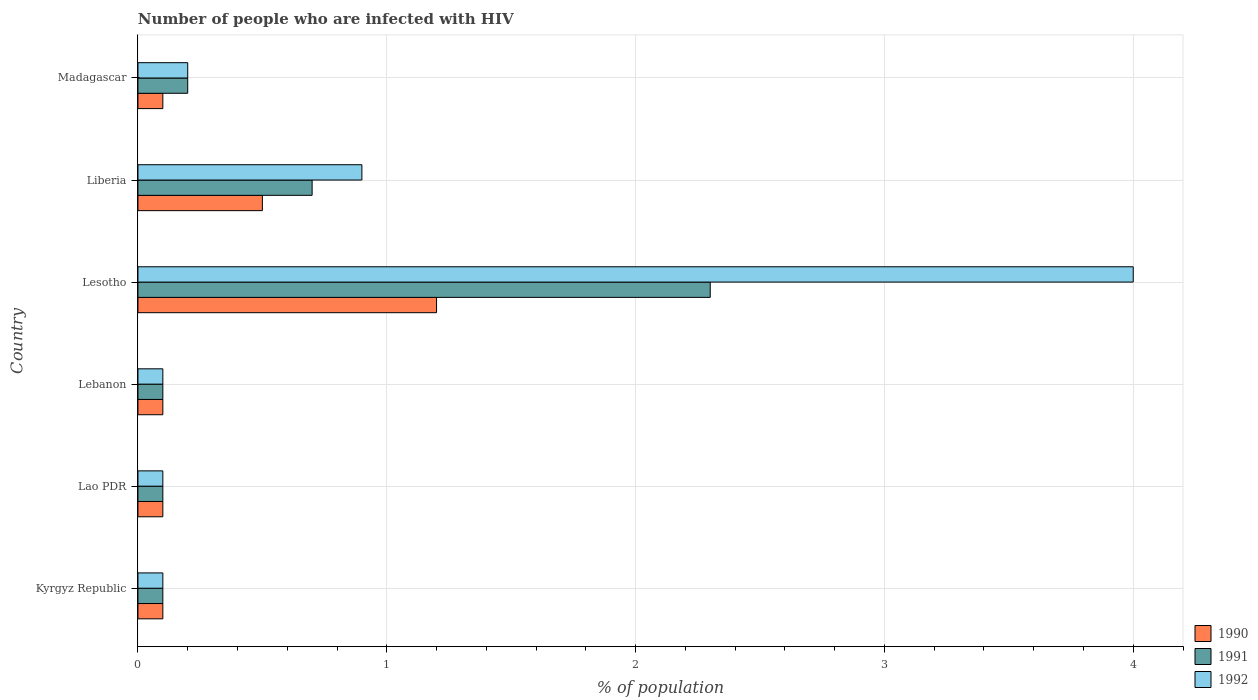How many bars are there on the 2nd tick from the top?
Make the answer very short. 3. How many bars are there on the 3rd tick from the bottom?
Provide a succinct answer. 3. What is the label of the 2nd group of bars from the top?
Your answer should be very brief. Liberia. In how many cases, is the number of bars for a given country not equal to the number of legend labels?
Your answer should be very brief. 0. What is the percentage of HIV infected population in in 1990 in Lebanon?
Ensure brevity in your answer.  0.1. Across all countries, what is the maximum percentage of HIV infected population in in 1990?
Your answer should be very brief. 1.2. Across all countries, what is the minimum percentage of HIV infected population in in 1991?
Keep it short and to the point. 0.1. In which country was the percentage of HIV infected population in in 1990 maximum?
Offer a very short reply. Lesotho. In which country was the percentage of HIV infected population in in 1992 minimum?
Your response must be concise. Kyrgyz Republic. What is the difference between the percentage of HIV infected population in in 1990 in Lao PDR and that in Lebanon?
Keep it short and to the point. 0. What is the average percentage of HIV infected population in in 1991 per country?
Give a very brief answer. 0.58. What is the difference between the percentage of HIV infected population in in 1990 and percentage of HIV infected population in in 1991 in Lao PDR?
Make the answer very short. 0. In how many countries, is the percentage of HIV infected population in in 1991 greater than 2.8 %?
Give a very brief answer. 0. What is the ratio of the percentage of HIV infected population in in 1992 in Lesotho to that in Madagascar?
Offer a very short reply. 20. What is the difference between the highest and the second highest percentage of HIV infected population in in 1990?
Ensure brevity in your answer.  0.7. What is the difference between the highest and the lowest percentage of HIV infected population in in 1991?
Offer a very short reply. 2.2. What does the 2nd bar from the top in Lebanon represents?
Make the answer very short. 1991. Is it the case that in every country, the sum of the percentage of HIV infected population in in 1992 and percentage of HIV infected population in in 1991 is greater than the percentage of HIV infected population in in 1990?
Make the answer very short. Yes. How many bars are there?
Provide a succinct answer. 18. How many countries are there in the graph?
Provide a succinct answer. 6. Where does the legend appear in the graph?
Your answer should be compact. Bottom right. What is the title of the graph?
Offer a very short reply. Number of people who are infected with HIV. What is the label or title of the X-axis?
Offer a terse response. % of population. What is the % of population in 1990 in Kyrgyz Republic?
Ensure brevity in your answer.  0.1. What is the % of population of 1991 in Kyrgyz Republic?
Your response must be concise. 0.1. What is the % of population in 1992 in Kyrgyz Republic?
Offer a terse response. 0.1. What is the % of population of 1990 in Lao PDR?
Offer a very short reply. 0.1. What is the % of population of 1992 in Lao PDR?
Provide a short and direct response. 0.1. What is the % of population in 1990 in Lebanon?
Offer a very short reply. 0.1. What is the % of population in 1991 in Lebanon?
Give a very brief answer. 0.1. What is the % of population in 1992 in Lebanon?
Offer a terse response. 0.1. What is the % of population of 1990 in Liberia?
Your response must be concise. 0.5. What is the % of population of 1991 in Liberia?
Give a very brief answer. 0.7. What is the % of population of 1992 in Liberia?
Provide a succinct answer. 0.9. What is the % of population of 1990 in Madagascar?
Make the answer very short. 0.1. What is the % of population in 1992 in Madagascar?
Provide a short and direct response. 0.2. Across all countries, what is the maximum % of population in 1991?
Ensure brevity in your answer.  2.3. Across all countries, what is the minimum % of population in 1991?
Keep it short and to the point. 0.1. Across all countries, what is the minimum % of population in 1992?
Your answer should be compact. 0.1. What is the difference between the % of population in 1990 in Kyrgyz Republic and that in Lao PDR?
Your answer should be compact. 0. What is the difference between the % of population in 1991 in Kyrgyz Republic and that in Lao PDR?
Ensure brevity in your answer.  0. What is the difference between the % of population of 1992 in Kyrgyz Republic and that in Lao PDR?
Offer a very short reply. 0. What is the difference between the % of population of 1992 in Kyrgyz Republic and that in Lebanon?
Keep it short and to the point. 0. What is the difference between the % of population in 1990 in Kyrgyz Republic and that in Lesotho?
Provide a succinct answer. -1.1. What is the difference between the % of population of 1992 in Kyrgyz Republic and that in Lesotho?
Your answer should be very brief. -3.9. What is the difference between the % of population in 1990 in Kyrgyz Republic and that in Liberia?
Make the answer very short. -0.4. What is the difference between the % of population in 1991 in Kyrgyz Republic and that in Liberia?
Make the answer very short. -0.6. What is the difference between the % of population in 1991 in Lao PDR and that in Lebanon?
Offer a very short reply. 0. What is the difference between the % of population of 1991 in Lao PDR and that in Liberia?
Offer a very short reply. -0.6. What is the difference between the % of population in 1991 in Lao PDR and that in Madagascar?
Your answer should be compact. -0.1. What is the difference between the % of population of 1992 in Lao PDR and that in Madagascar?
Offer a very short reply. -0.1. What is the difference between the % of population in 1990 in Lebanon and that in Lesotho?
Give a very brief answer. -1.1. What is the difference between the % of population of 1991 in Lebanon and that in Lesotho?
Give a very brief answer. -2.2. What is the difference between the % of population in 1991 in Lebanon and that in Liberia?
Your answer should be very brief. -0.6. What is the difference between the % of population in 1992 in Lebanon and that in Liberia?
Keep it short and to the point. -0.8. What is the difference between the % of population in 1990 in Lebanon and that in Madagascar?
Offer a very short reply. 0. What is the difference between the % of population in 1990 in Lesotho and that in Liberia?
Ensure brevity in your answer.  0.7. What is the difference between the % of population of 1992 in Lesotho and that in Liberia?
Offer a terse response. 3.1. What is the difference between the % of population of 1992 in Lesotho and that in Madagascar?
Offer a very short reply. 3.8. What is the difference between the % of population in 1991 in Liberia and that in Madagascar?
Your answer should be very brief. 0.5. What is the difference between the % of population of 1990 in Kyrgyz Republic and the % of population of 1992 in Lao PDR?
Offer a very short reply. 0. What is the difference between the % of population in 1990 in Kyrgyz Republic and the % of population in 1992 in Lebanon?
Offer a very short reply. 0. What is the difference between the % of population in 1990 in Kyrgyz Republic and the % of population in 1991 in Lesotho?
Offer a very short reply. -2.2. What is the difference between the % of population in 1991 in Kyrgyz Republic and the % of population in 1992 in Lesotho?
Offer a terse response. -3.9. What is the difference between the % of population in 1990 in Kyrgyz Republic and the % of population in 1992 in Liberia?
Your answer should be very brief. -0.8. What is the difference between the % of population in 1990 in Kyrgyz Republic and the % of population in 1992 in Madagascar?
Make the answer very short. -0.1. What is the difference between the % of population in 1991 in Kyrgyz Republic and the % of population in 1992 in Madagascar?
Give a very brief answer. -0.1. What is the difference between the % of population of 1990 in Lao PDR and the % of population of 1992 in Lesotho?
Provide a succinct answer. -3.9. What is the difference between the % of population in 1990 in Lao PDR and the % of population in 1991 in Liberia?
Provide a succinct answer. -0.6. What is the difference between the % of population in 1991 in Lao PDR and the % of population in 1992 in Liberia?
Your answer should be very brief. -0.8. What is the difference between the % of population in 1990 in Lao PDR and the % of population in 1991 in Madagascar?
Make the answer very short. -0.1. What is the difference between the % of population in 1990 in Lao PDR and the % of population in 1992 in Madagascar?
Provide a succinct answer. -0.1. What is the difference between the % of population in 1991 in Lao PDR and the % of population in 1992 in Madagascar?
Provide a succinct answer. -0.1. What is the difference between the % of population of 1991 in Lebanon and the % of population of 1992 in Liberia?
Your answer should be compact. -0.8. What is the difference between the % of population in 1990 in Lebanon and the % of population in 1991 in Madagascar?
Make the answer very short. -0.1. What is the difference between the % of population in 1990 in Lebanon and the % of population in 1992 in Madagascar?
Make the answer very short. -0.1. What is the difference between the % of population in 1991 in Lebanon and the % of population in 1992 in Madagascar?
Provide a succinct answer. -0.1. What is the difference between the % of population of 1990 in Lesotho and the % of population of 1991 in Liberia?
Ensure brevity in your answer.  0.5. What is the difference between the % of population in 1990 in Lesotho and the % of population in 1992 in Liberia?
Offer a terse response. 0.3. What is the difference between the % of population in 1990 in Lesotho and the % of population in 1992 in Madagascar?
Make the answer very short. 1. What is the difference between the % of population of 1991 in Lesotho and the % of population of 1992 in Madagascar?
Your answer should be very brief. 2.1. What is the difference between the % of population in 1990 in Liberia and the % of population in 1991 in Madagascar?
Your response must be concise. 0.3. What is the difference between the % of population of 1990 in Liberia and the % of population of 1992 in Madagascar?
Offer a very short reply. 0.3. What is the difference between the % of population of 1991 in Liberia and the % of population of 1992 in Madagascar?
Provide a short and direct response. 0.5. What is the average % of population in 1990 per country?
Give a very brief answer. 0.35. What is the average % of population in 1991 per country?
Keep it short and to the point. 0.58. What is the difference between the % of population in 1990 and % of population in 1992 in Kyrgyz Republic?
Provide a short and direct response. 0. What is the difference between the % of population of 1991 and % of population of 1992 in Kyrgyz Republic?
Ensure brevity in your answer.  0. What is the difference between the % of population of 1990 and % of population of 1991 in Lao PDR?
Offer a terse response. 0. What is the difference between the % of population of 1990 and % of population of 1992 in Lao PDR?
Offer a very short reply. 0. What is the difference between the % of population of 1991 and % of population of 1992 in Lao PDR?
Make the answer very short. 0. What is the difference between the % of population of 1990 and % of population of 1991 in Lebanon?
Offer a very short reply. 0. What is the difference between the % of population of 1990 and % of population of 1992 in Lesotho?
Provide a short and direct response. -2.8. What is the difference between the % of population in 1990 and % of population in 1991 in Liberia?
Give a very brief answer. -0.2. What is the difference between the % of population in 1991 and % of population in 1992 in Liberia?
Offer a terse response. -0.2. What is the ratio of the % of population of 1991 in Kyrgyz Republic to that in Lao PDR?
Keep it short and to the point. 1. What is the ratio of the % of population in 1992 in Kyrgyz Republic to that in Lao PDR?
Provide a short and direct response. 1. What is the ratio of the % of population of 1990 in Kyrgyz Republic to that in Lebanon?
Your response must be concise. 1. What is the ratio of the % of population of 1990 in Kyrgyz Republic to that in Lesotho?
Offer a terse response. 0.08. What is the ratio of the % of population of 1991 in Kyrgyz Republic to that in Lesotho?
Provide a short and direct response. 0.04. What is the ratio of the % of population of 1992 in Kyrgyz Republic to that in Lesotho?
Your answer should be compact. 0.03. What is the ratio of the % of population in 1990 in Kyrgyz Republic to that in Liberia?
Your answer should be very brief. 0.2. What is the ratio of the % of population in 1991 in Kyrgyz Republic to that in Liberia?
Offer a very short reply. 0.14. What is the ratio of the % of population of 1992 in Kyrgyz Republic to that in Liberia?
Offer a terse response. 0.11. What is the ratio of the % of population of 1990 in Kyrgyz Republic to that in Madagascar?
Provide a short and direct response. 1. What is the ratio of the % of population in 1991 in Lao PDR to that in Lebanon?
Your answer should be very brief. 1. What is the ratio of the % of population in 1992 in Lao PDR to that in Lebanon?
Keep it short and to the point. 1. What is the ratio of the % of population of 1990 in Lao PDR to that in Lesotho?
Your answer should be compact. 0.08. What is the ratio of the % of population in 1991 in Lao PDR to that in Lesotho?
Keep it short and to the point. 0.04. What is the ratio of the % of population of 1992 in Lao PDR to that in Lesotho?
Provide a succinct answer. 0.03. What is the ratio of the % of population in 1990 in Lao PDR to that in Liberia?
Make the answer very short. 0.2. What is the ratio of the % of population in 1991 in Lao PDR to that in Liberia?
Offer a very short reply. 0.14. What is the ratio of the % of population in 1992 in Lao PDR to that in Liberia?
Provide a succinct answer. 0.11. What is the ratio of the % of population of 1990 in Lao PDR to that in Madagascar?
Keep it short and to the point. 1. What is the ratio of the % of population in 1992 in Lao PDR to that in Madagascar?
Make the answer very short. 0.5. What is the ratio of the % of population in 1990 in Lebanon to that in Lesotho?
Offer a very short reply. 0.08. What is the ratio of the % of population in 1991 in Lebanon to that in Lesotho?
Provide a succinct answer. 0.04. What is the ratio of the % of population of 1992 in Lebanon to that in Lesotho?
Keep it short and to the point. 0.03. What is the ratio of the % of population of 1990 in Lebanon to that in Liberia?
Provide a short and direct response. 0.2. What is the ratio of the % of population in 1991 in Lebanon to that in Liberia?
Keep it short and to the point. 0.14. What is the ratio of the % of population of 1992 in Lebanon to that in Liberia?
Your answer should be compact. 0.11. What is the ratio of the % of population in 1992 in Lebanon to that in Madagascar?
Offer a terse response. 0.5. What is the ratio of the % of population in 1990 in Lesotho to that in Liberia?
Your response must be concise. 2.4. What is the ratio of the % of population of 1991 in Lesotho to that in Liberia?
Your response must be concise. 3.29. What is the ratio of the % of population in 1992 in Lesotho to that in Liberia?
Give a very brief answer. 4.44. What is the ratio of the % of population in 1990 in Lesotho to that in Madagascar?
Make the answer very short. 12. What is the ratio of the % of population in 1992 in Lesotho to that in Madagascar?
Give a very brief answer. 20. What is the difference between the highest and the second highest % of population in 1991?
Provide a short and direct response. 1.6. What is the difference between the highest and the lowest % of population of 1990?
Provide a short and direct response. 1.1. What is the difference between the highest and the lowest % of population of 1992?
Offer a terse response. 3.9. 